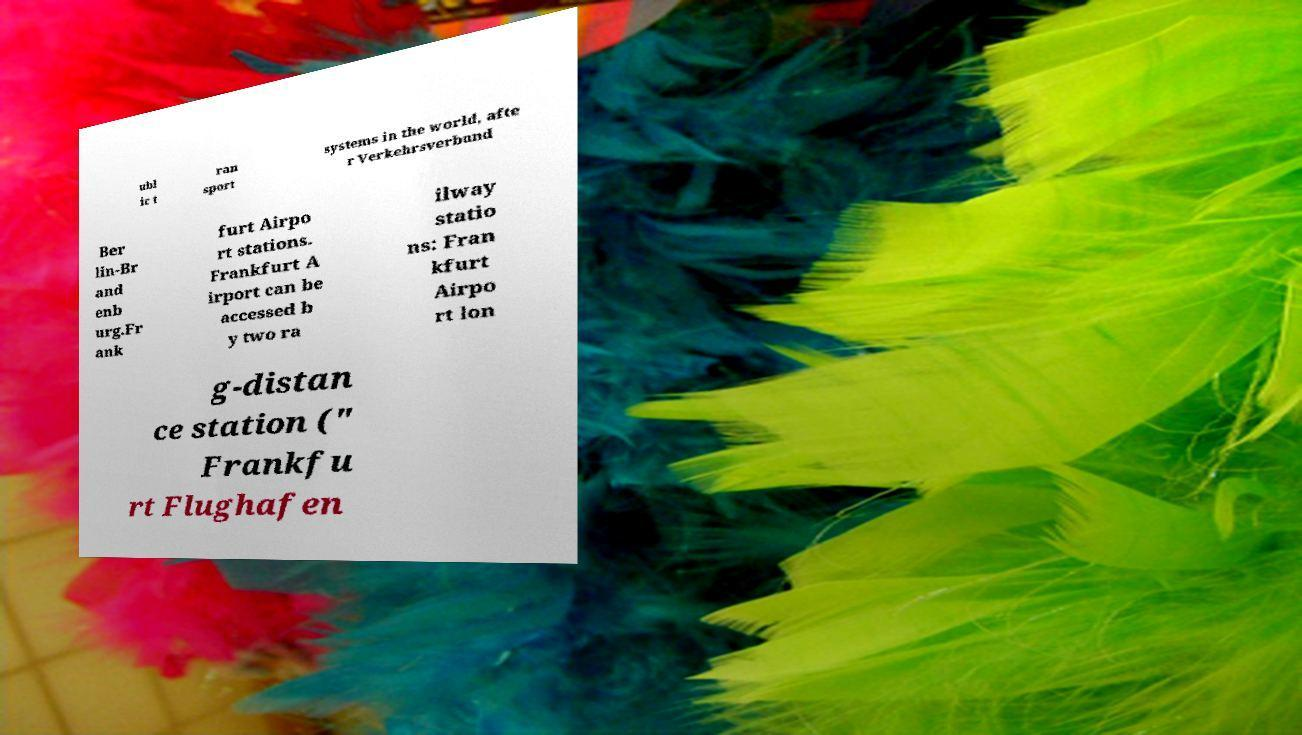Can you accurately transcribe the text from the provided image for me? ubl ic t ran sport systems in the world, afte r Verkehrsverbund Ber lin-Br and enb urg.Fr ank furt Airpo rt stations. Frankfurt A irport can be accessed b y two ra ilway statio ns: Fran kfurt Airpo rt lon g-distan ce station (" Frankfu rt Flughafen 